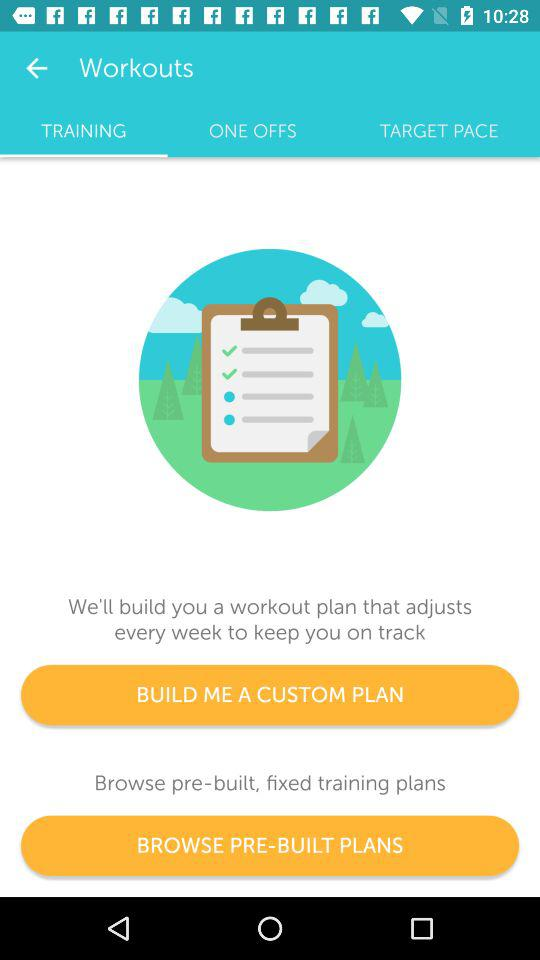Which tab is selected? The selected tab is training. 